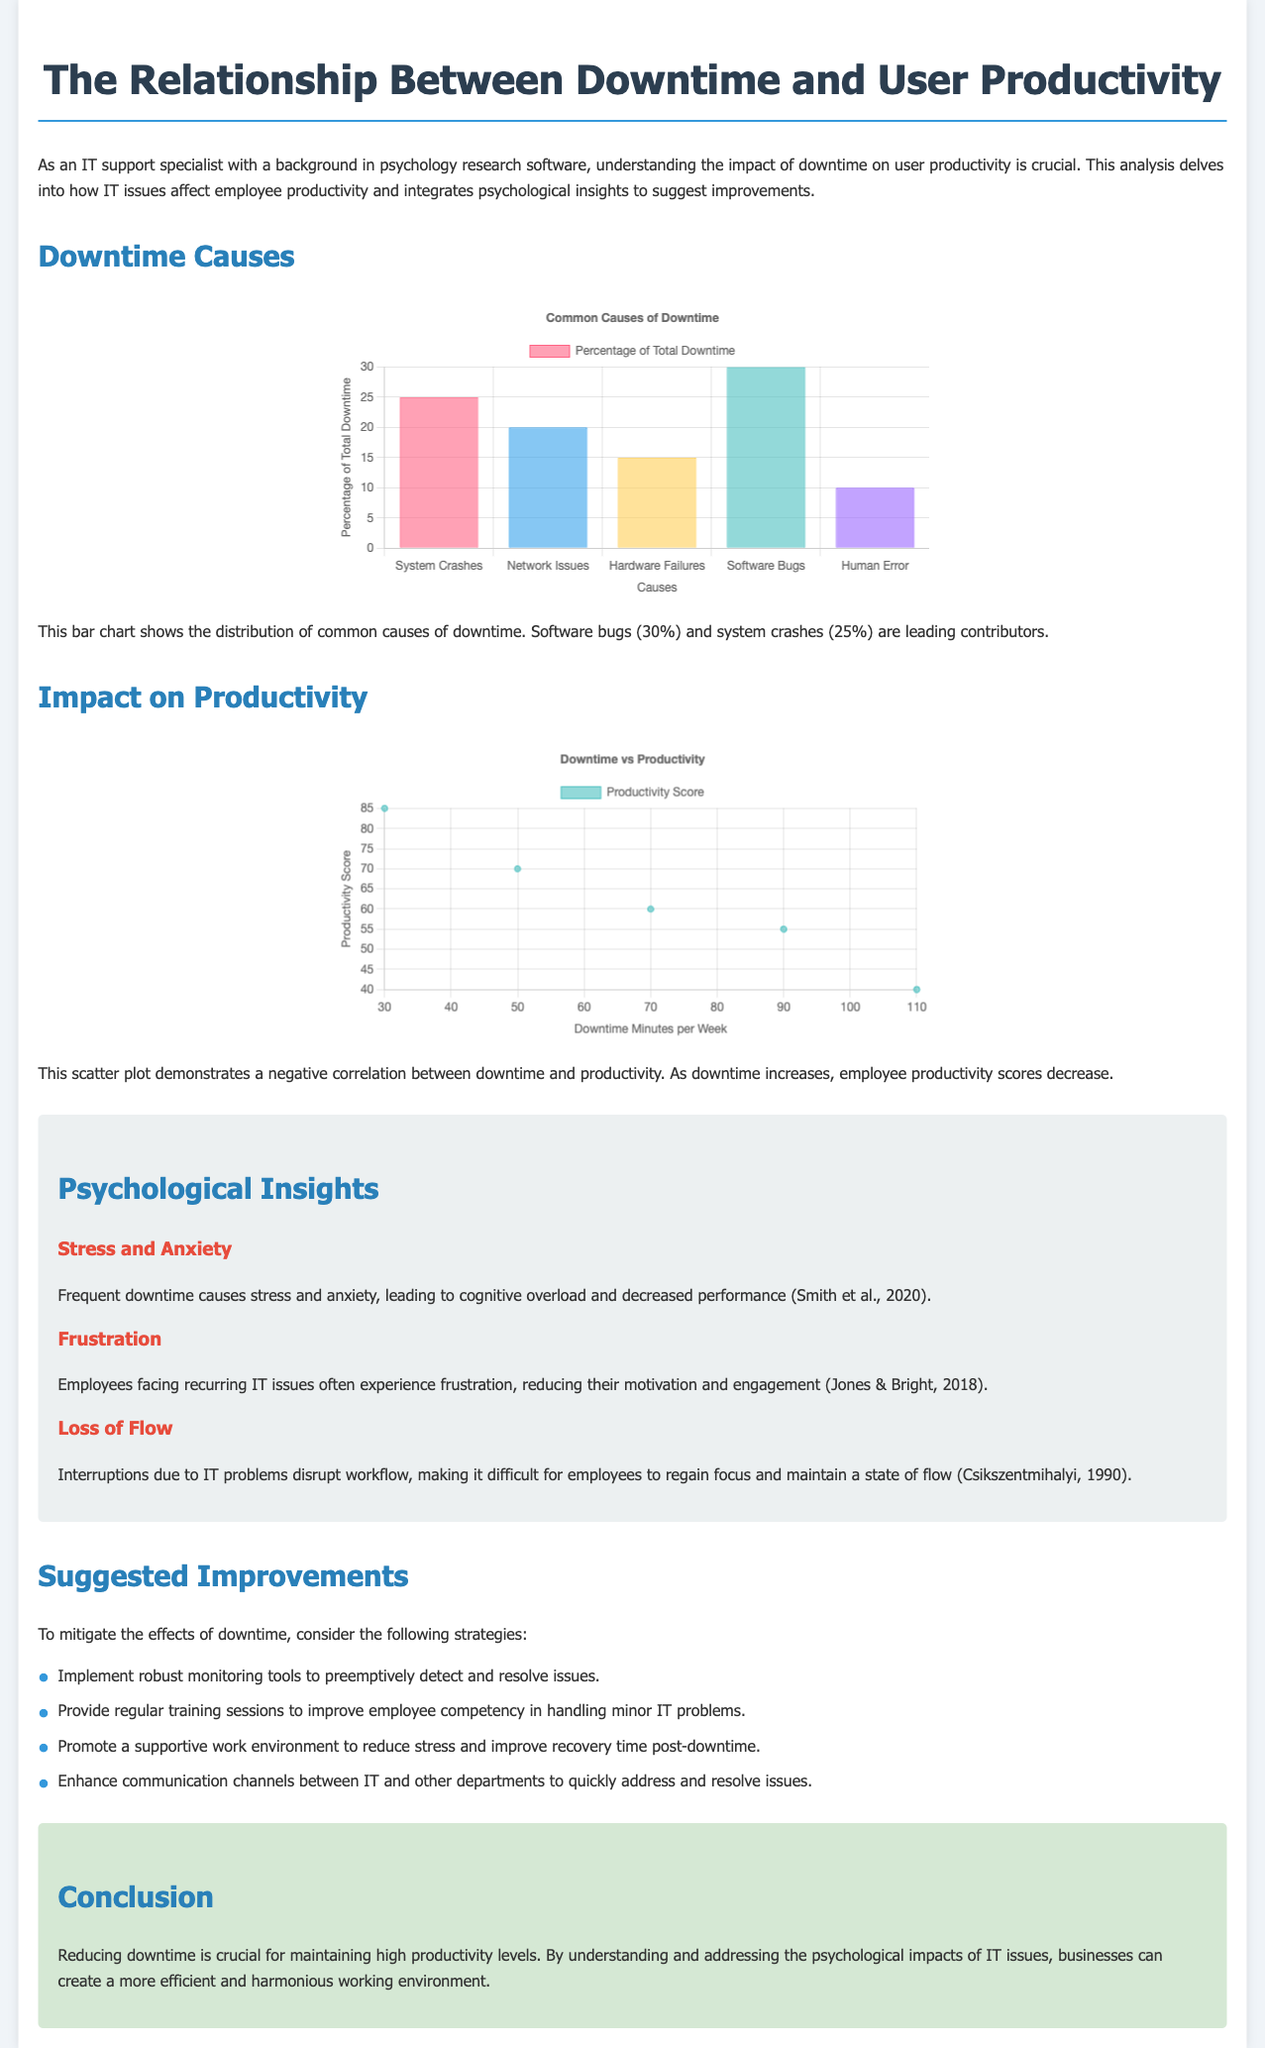What are the two leading causes of downtime? The document mentions software bugs and system crashes as the leading causes of downtime.
Answer: Software bugs, system crashes What percentage of total downtime is due to hardware failures? The document states that hardware failures account for 15% of total downtime.
Answer: 15% What type of chart depicts the relationship between downtime and productivity? The document specifies that a scatter plot demonstrates this relationship.
Answer: Scatter plot What effect does frequent downtime have on employee stress levels? The document indicates that frequent downtime causes stress and anxiety, reducing performance.
Answer: Stress and anxiety What is the suggested strategy to enhance communication between IT and other departments? The document suggests enhancing communication channels to quickly address issues as a strategy.
Answer: Enhance communication channels 